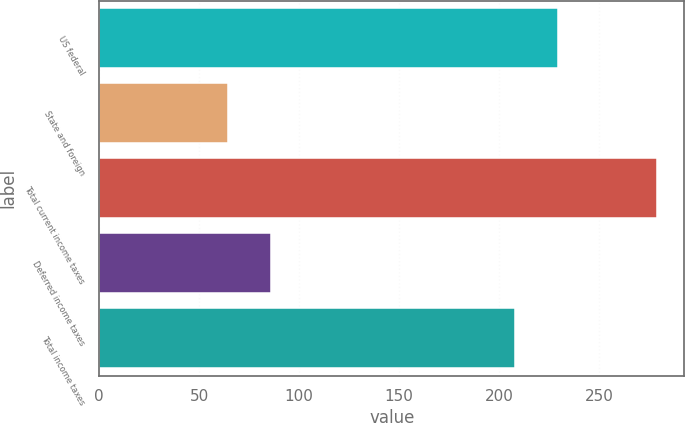Convert chart to OTSL. <chart><loc_0><loc_0><loc_500><loc_500><bar_chart><fcel>US federal<fcel>State and foreign<fcel>Total current income taxes<fcel>Deferred income taxes<fcel>Total income taxes<nl><fcel>229.56<fcel>64.3<fcel>278.9<fcel>85.76<fcel>208.1<nl></chart> 